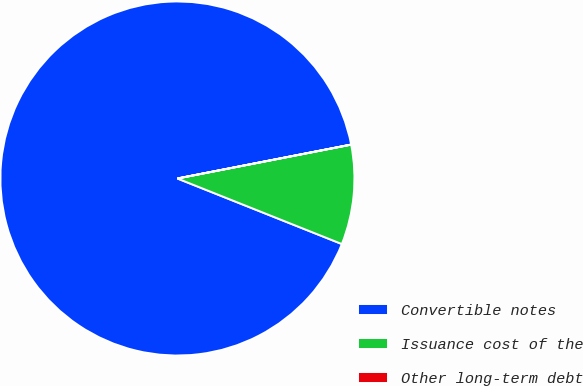<chart> <loc_0><loc_0><loc_500><loc_500><pie_chart><fcel>Convertible notes<fcel>Issuance cost of the<fcel>Other long-term debt<nl><fcel>90.9%<fcel>9.1%<fcel>0.01%<nl></chart> 